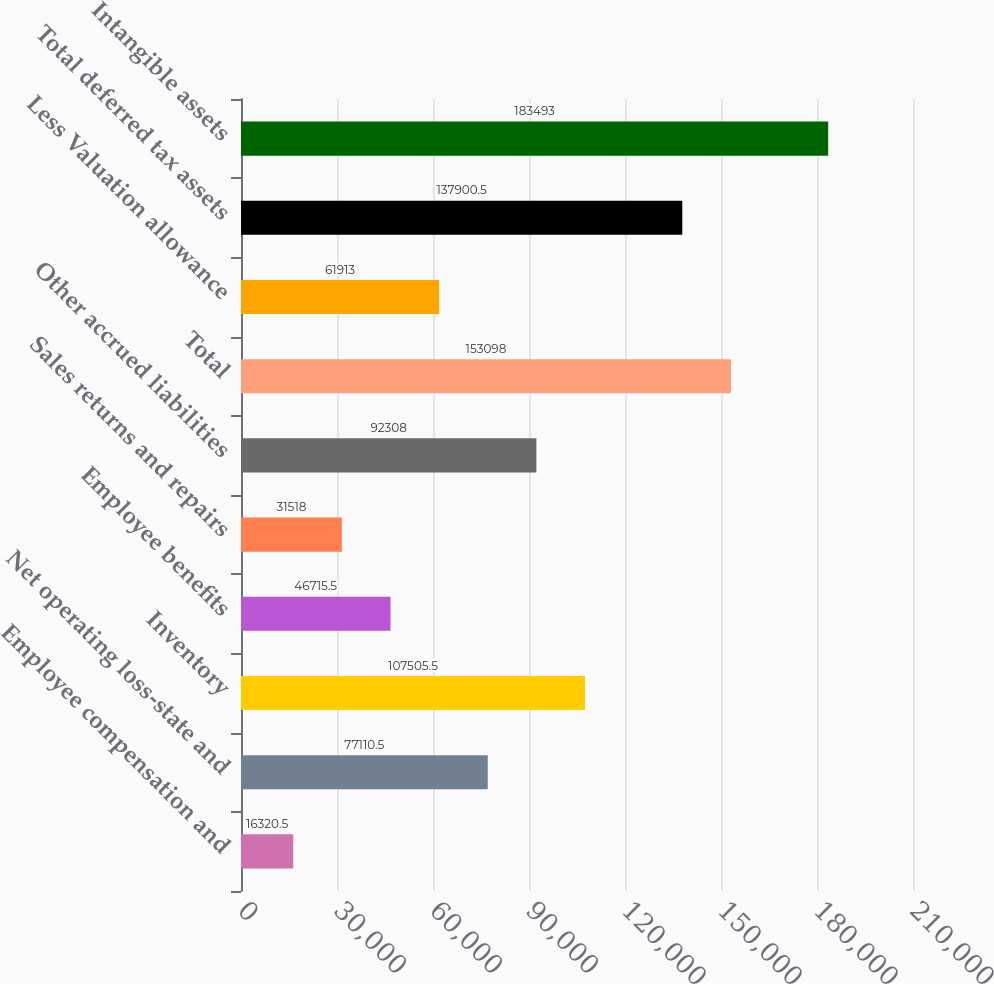Convert chart to OTSL. <chart><loc_0><loc_0><loc_500><loc_500><bar_chart><fcel>Employee compensation and<fcel>Net operating loss-state and<fcel>Inventory<fcel>Employee benefits<fcel>Sales returns and repairs<fcel>Other accrued liabilities<fcel>Total<fcel>Less Valuation allowance<fcel>Total deferred tax assets<fcel>Intangible assets<nl><fcel>16320.5<fcel>77110.5<fcel>107506<fcel>46715.5<fcel>31518<fcel>92308<fcel>153098<fcel>61913<fcel>137900<fcel>183493<nl></chart> 